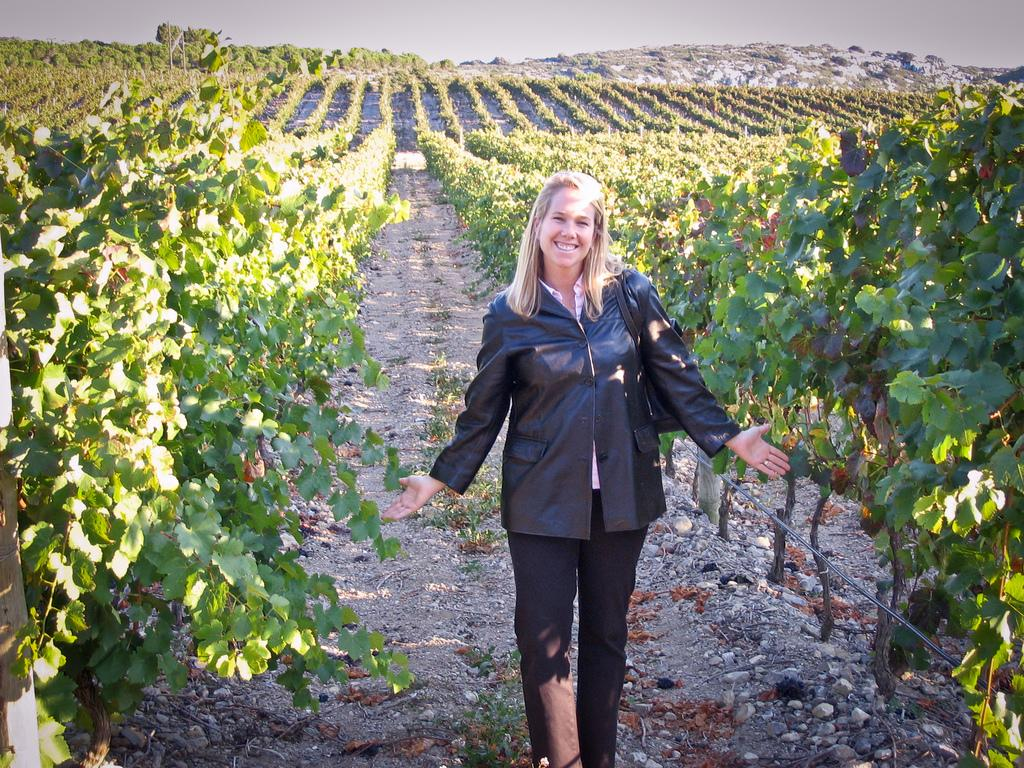Who is the main subject in the foreground of the image? There is a lady standing in the foreground of the image. What type of vegetation can be seen in the image? There are plants in series in the image. What geographical feature is depicted in the image? The image appears to depict a mountain. What is visible in the background of the image? The sky is visible in the background of the image. What type of tray is being used to carry the mountain in the image? There is no tray present in the image, and the mountain is not being carried. 